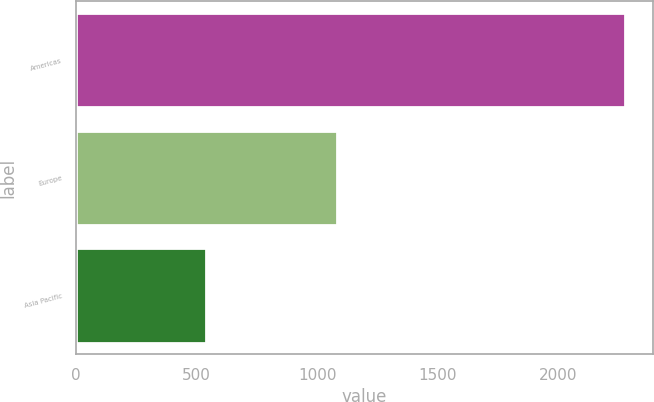<chart> <loc_0><loc_0><loc_500><loc_500><bar_chart><fcel>Americas<fcel>Europe<fcel>Asia Pacific<nl><fcel>2277<fcel>1081<fcel>539.5<nl></chart> 